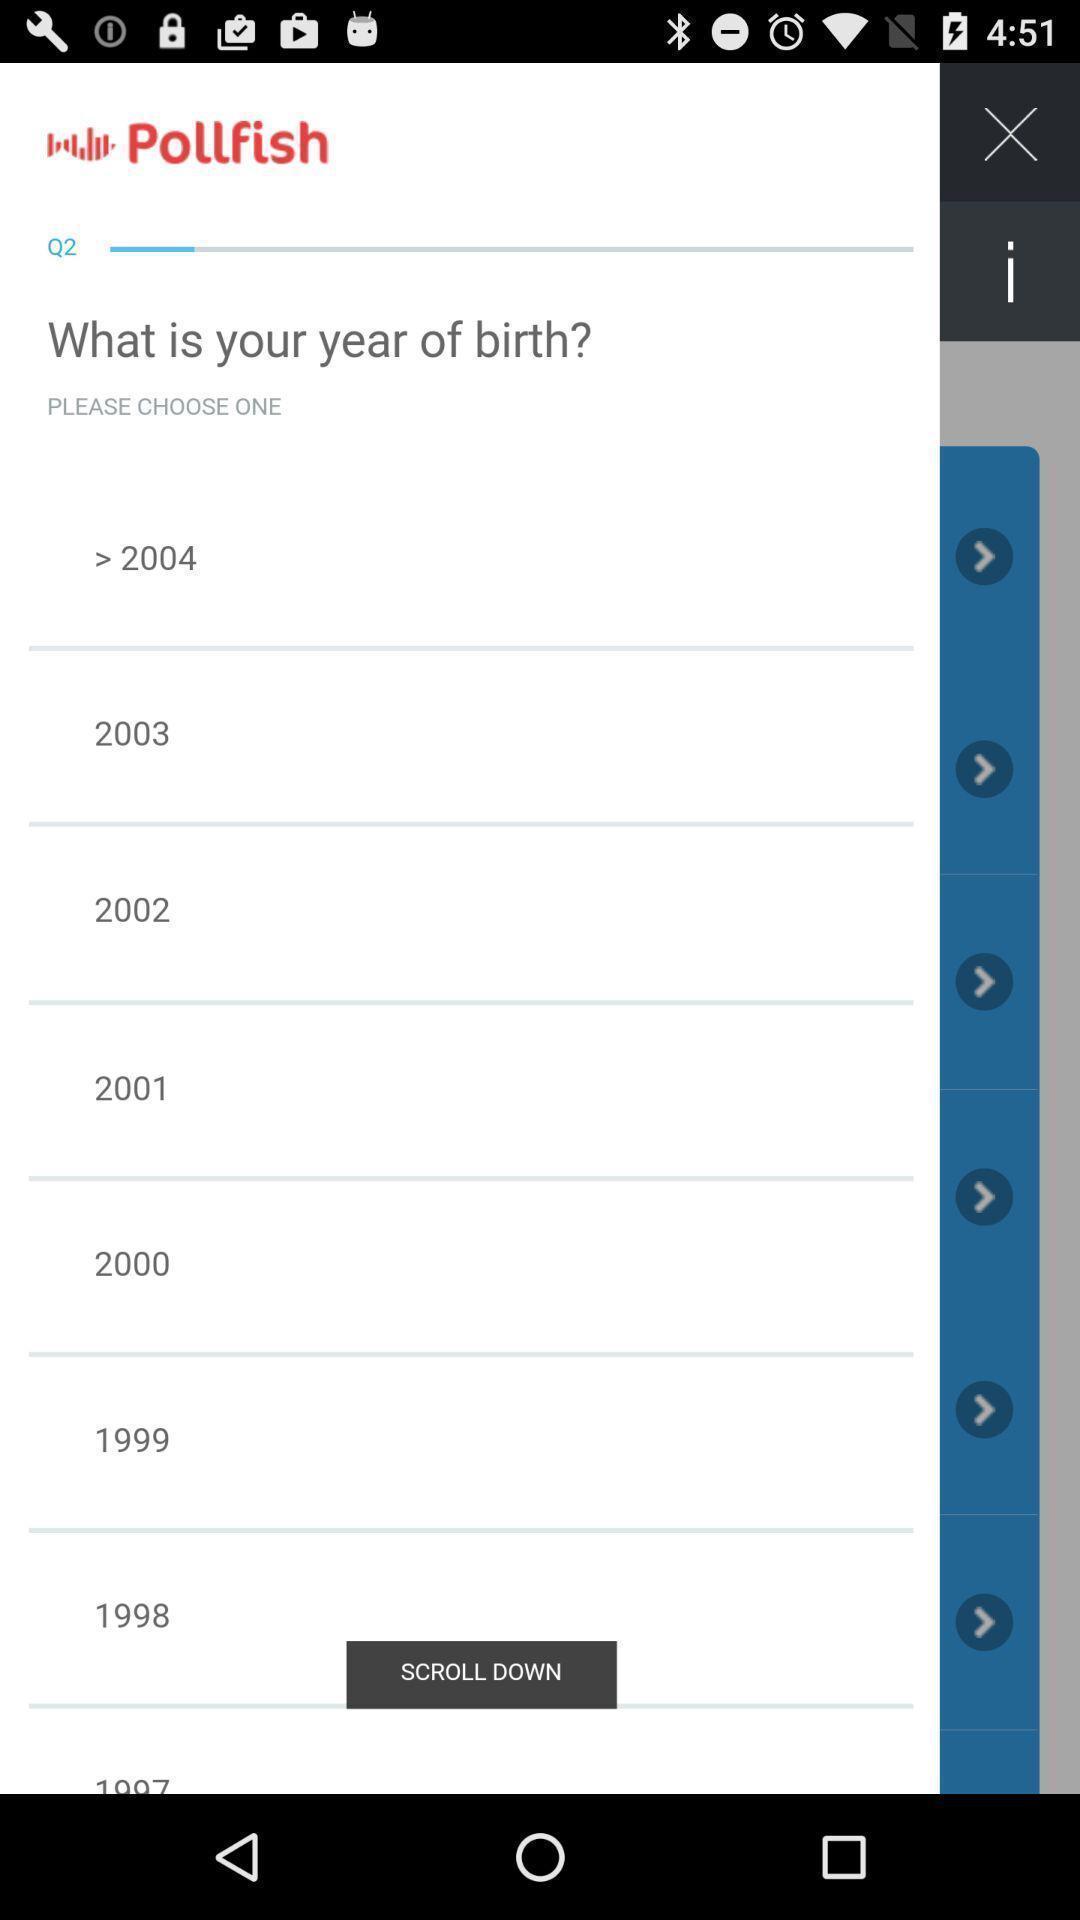Summarize the main components in this picture. Pop up asking about year of birth. 